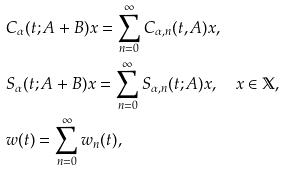Convert formula to latex. <formula><loc_0><loc_0><loc_500><loc_500>& C _ { \alpha } ( t ; A + B ) x = \sum _ { n = 0 } ^ { \infty } C _ { \alpha , n } ( t , A ) x , \\ & S _ { \alpha } ( t ; A + B ) x = \sum _ { n = 0 } ^ { \infty } S _ { \alpha , n } ( t ; A ) x , \quad x \in \mathbb { X } , \\ & w ( t ) = \sum _ { n = 0 } ^ { \infty } w _ { n } ( t ) ,</formula> 